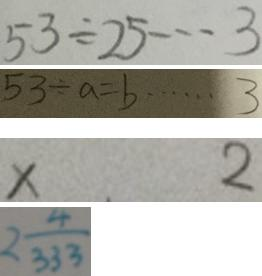<formula> <loc_0><loc_0><loc_500><loc_500>5 3 \div 2 5 \cdots 3 
 5 3 \div a = b \cdots 3 
 x . 2 
 2 \frac { 4 } { 3 3 3 }</formula> 